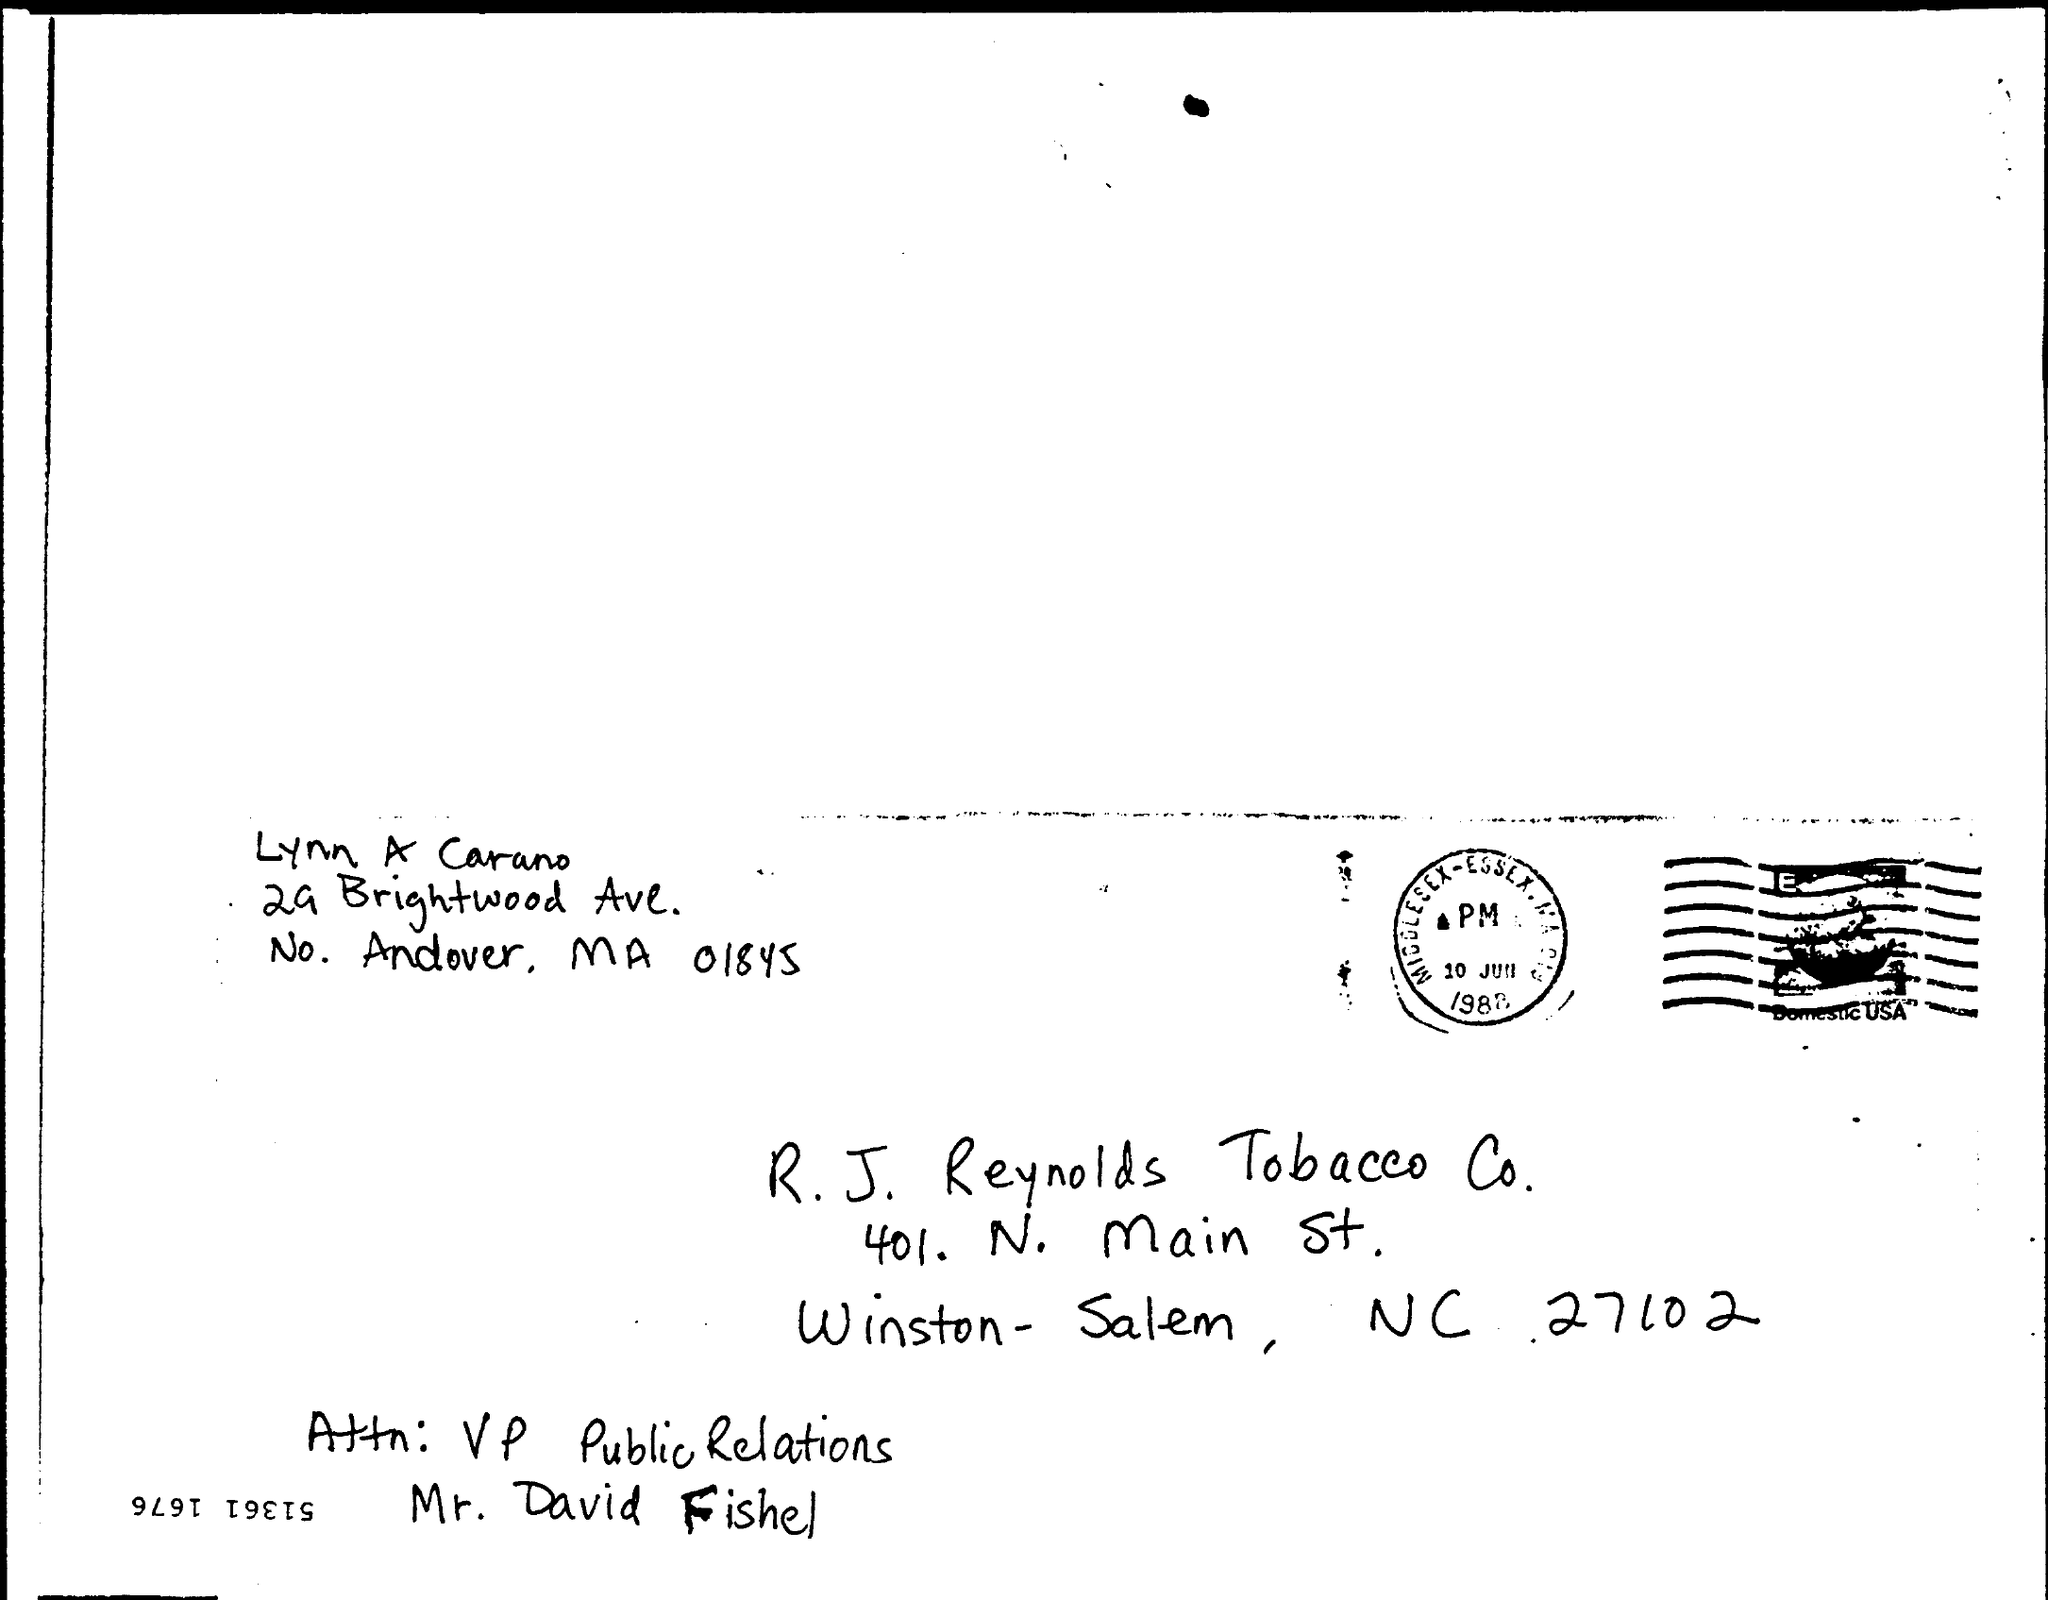Specify some key components in this picture. The letter is from Lynn A Carano. 